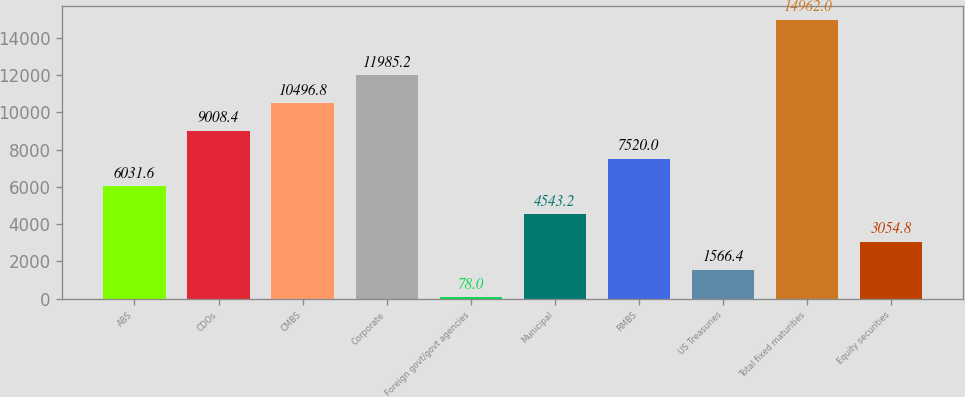Convert chart to OTSL. <chart><loc_0><loc_0><loc_500><loc_500><bar_chart><fcel>ABS<fcel>CDOs<fcel>CMBS<fcel>Corporate<fcel>Foreign govt/govt agencies<fcel>Municipal<fcel>RMBS<fcel>US Treasuries<fcel>Total fixed maturities<fcel>Equity securities<nl><fcel>6031.6<fcel>9008.4<fcel>10496.8<fcel>11985.2<fcel>78<fcel>4543.2<fcel>7520<fcel>1566.4<fcel>14962<fcel>3054.8<nl></chart> 